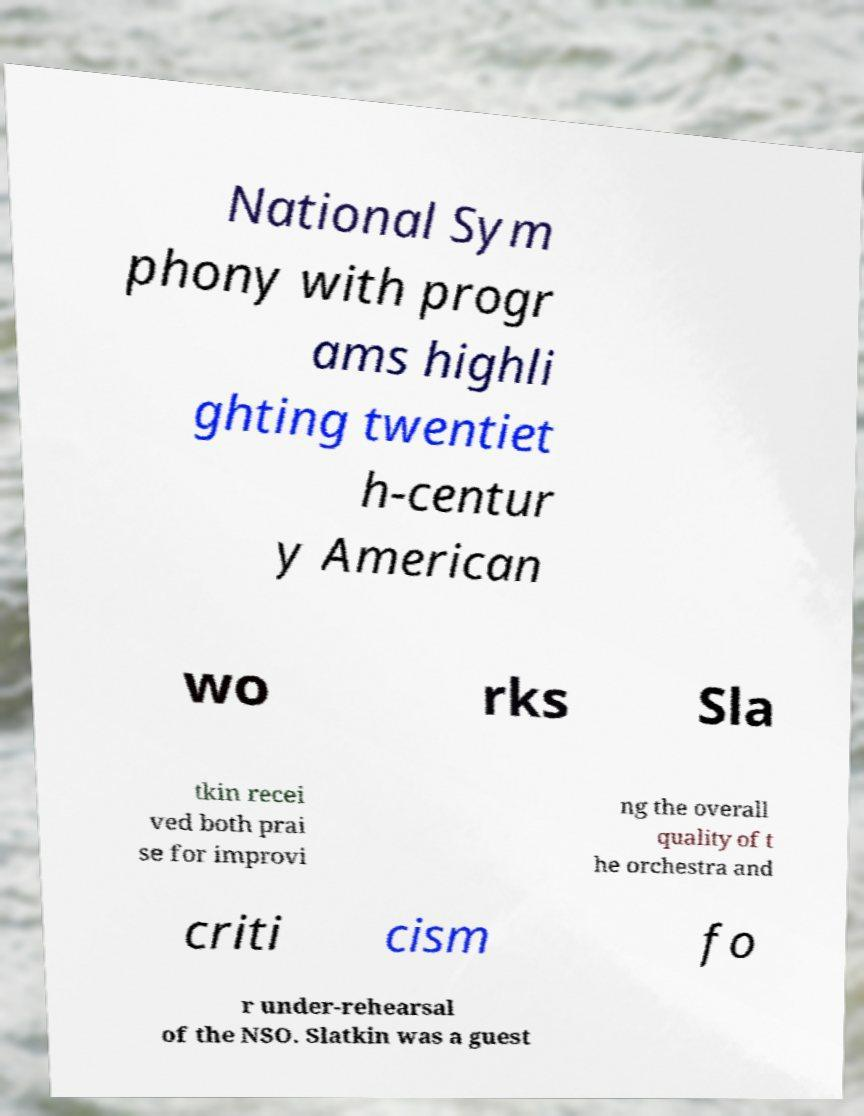Can you accurately transcribe the text from the provided image for me? National Sym phony with progr ams highli ghting twentiet h-centur y American wo rks Sla tkin recei ved both prai se for improvi ng the overall quality of t he orchestra and criti cism fo r under-rehearsal of the NSO. Slatkin was a guest 